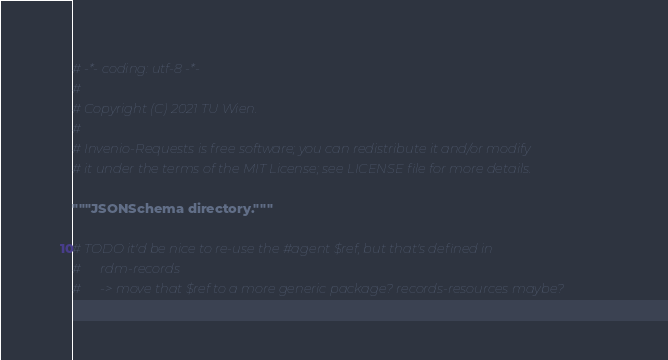<code> <loc_0><loc_0><loc_500><loc_500><_Python_># -*- coding: utf-8 -*-
#
# Copyright (C) 2021 TU Wien.
#
# Invenio-Requests is free software; you can redistribute it and/or modify
# it under the terms of the MIT License; see LICENSE file for more details.

"""JSONSchema directory."""

# TODO it'd be nice to re-use the #agent $ref, but that's defined in
#      rdm-records
#      -> move that $ref to a more generic package? records-resources maybe?
</code> 